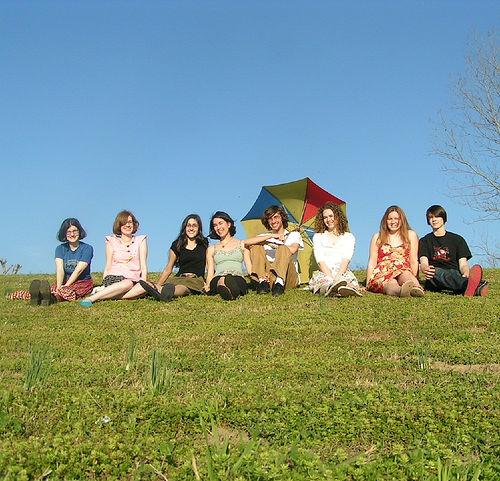How many males are in the picture?
Write a very short answer. 2. How many people are in the picture?
Give a very brief answer. 8. Does the woman have her hair in a ponytail?
Short answer required. No. Is it cloudy?
Quick response, please. No. Is this an urban setting?
Give a very brief answer. No. What object is behind the man and woman in the middle of the group?
Give a very brief answer. Umbrella. Are they all sitting on the lawn?
Answer briefly. Yes. Are they having a summer party?
Quick response, please. Yes. What is kid in yellow doing?
Write a very short answer. Sitting. 